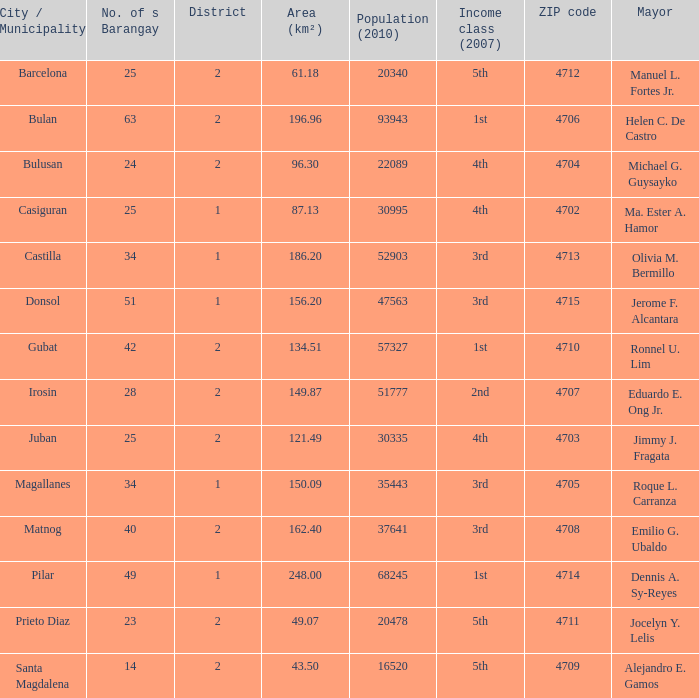What are all the vicinity (km²) where profits magnificence (2007) is 2nd 149.87. 